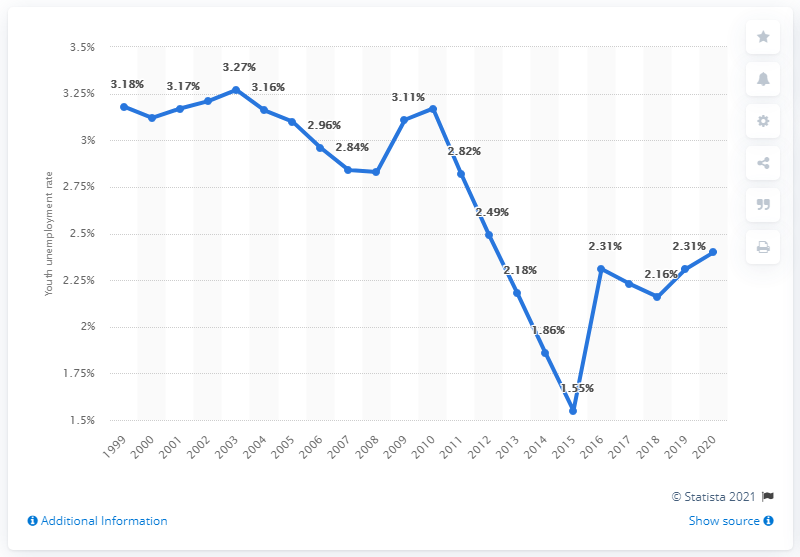Highlight a few significant elements in this photo. In 2020, the youth unemployment rate in Liberia was 2.4%. 